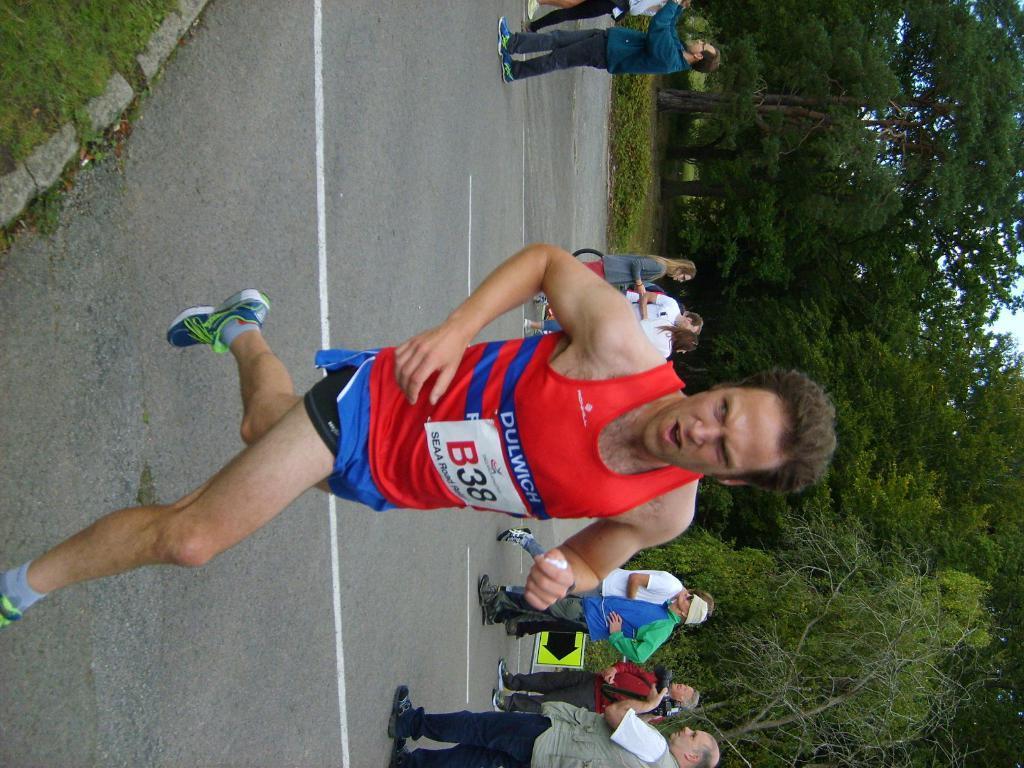How would you summarize this image in a sentence or two? In this picture I can see a man running, there are group of people standing, there is a kind of board, and in the background there are trees. 